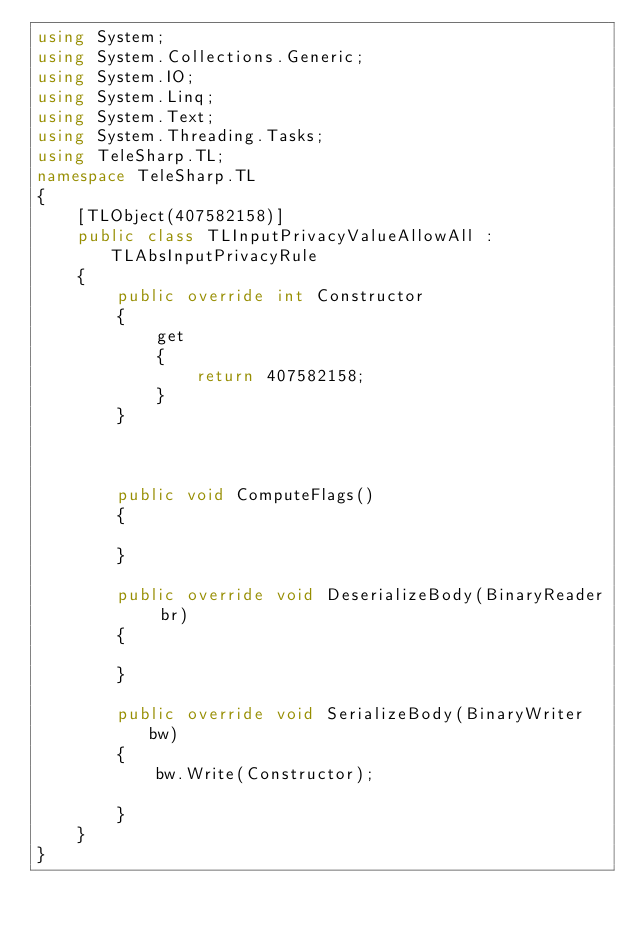<code> <loc_0><loc_0><loc_500><loc_500><_C#_>using System;
using System.Collections.Generic;
using System.IO;
using System.Linq;
using System.Text;
using System.Threading.Tasks;
using TeleSharp.TL;
namespace TeleSharp.TL
{
    [TLObject(407582158)]
    public class TLInputPrivacyValueAllowAll : TLAbsInputPrivacyRule
    {
        public override int Constructor
        {
            get
            {
                return 407582158;
            }
        }



        public void ComputeFlags()
        {

        }

        public override void DeserializeBody(BinaryReader br)
        {

        }

        public override void SerializeBody(BinaryWriter bw)
        {
            bw.Write(Constructor);

        }
    }
}
</code> 